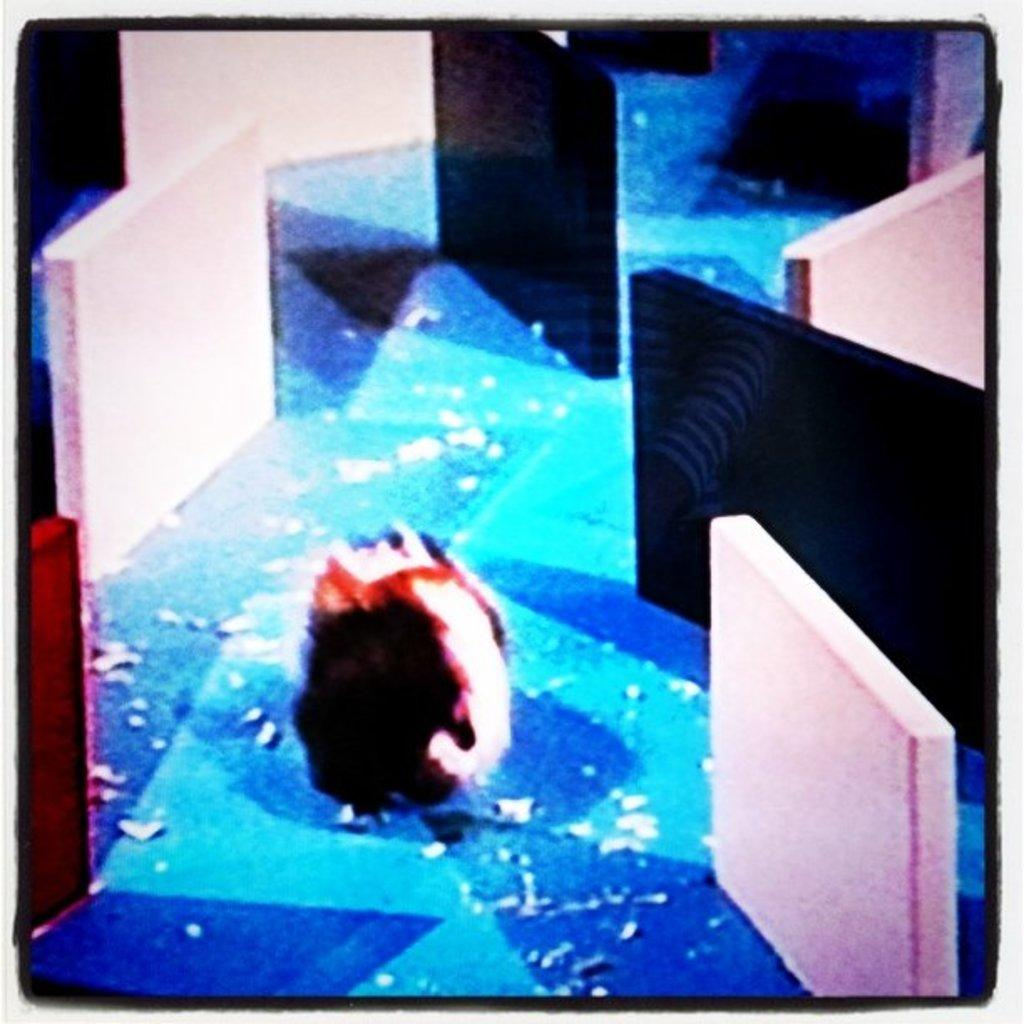What is the color of the surface on which the object is placed? The surface is blue. What type of objects are in front of the main object? There are black and white objects in front of the main object. What type of objects are beside the main object? There are also black and white objects beside the main object. What type of sock is the person wearing in the image? There is no person or sock present in the image. What is the person learning in the image? There is no person or learning activity depicted in the image. What type of kettle is visible in the image? There is no kettle present in the image. 